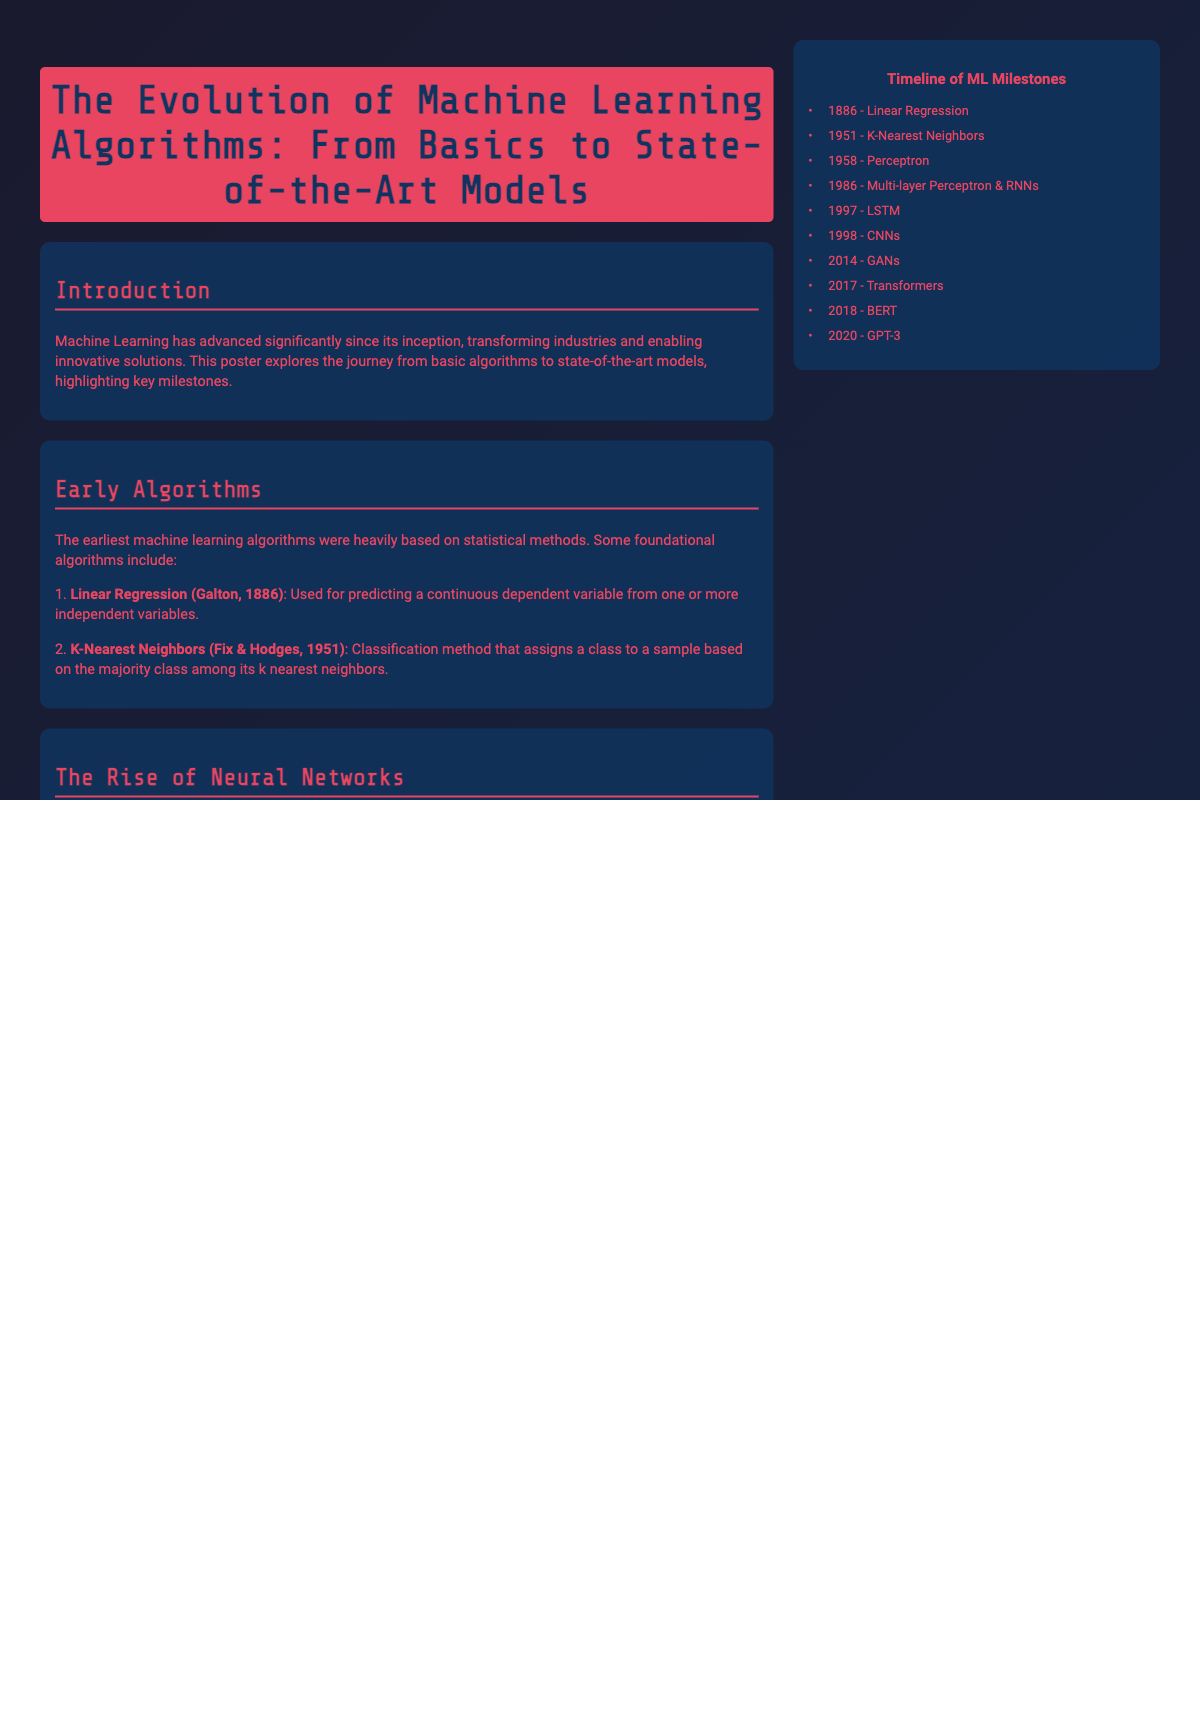What was the first machine learning algorithm mentioned? The document states that Linear Regression was the first machine learning algorithm mentioned, introduced by Galton in 1886.
Answer: Linear Regression Who introduced the Perceptron model? The document attributes the introduction of the Perceptron model to Rosenblatt in 1958.
Answer: Rosenblatt What significant advancement occurred in 1998? According to the document, Convolutional Neural Networks (CNNs) were introduced in 1998, revolutionizing computer vision tasks.
Answer: Convolutional Neural Networks Which model is used for sequential data? The poster mentions that Recurrent Neural Networks (RNNs) are effective for sequential data processing.
Answer: Recurrent Neural Networks What year was the Generative Adversarial Network (GAN) introduced? The document states that GANs were introduced in 2014, marking a key milestone in machine learning.
Answer: 2014 What does the timeline highlight? The timeline outlines key milestones in machine learning from the introduction of Linear Regression to GPT-3.
Answer: Key milestones What type of algorithms were early machine learning methods primarily based on? The early machine learning algorithms were primarily based on statistical methods.
Answer: Statistical methods Which modern model transformed natural language processing? The poster indicates that Transformers transformed natural language processing.
Answer: Transformers What is one key visualization mentioned in the document? The poster lists various model visualizations, with a diagram of a simple Perceptron being one key example.
Answer: Diagram of a simple Perceptron 